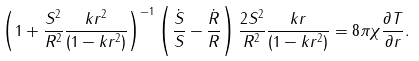Convert formula to latex. <formula><loc_0><loc_0><loc_500><loc_500>\left ( 1 + \frac { S ^ { 2 } } { R ^ { 2 } } \frac { k r ^ { 2 } } { ( 1 - k r ^ { 2 } ) } \right ) ^ { - 1 } \left ( \frac { \dot { S } } { S } - \frac { \dot { R } } { R } \right ) \frac { 2 S ^ { 2 } } { R ^ { 2 } } \frac { k r } { ( 1 - k r ^ { 2 } ) } = 8 \pi \chi \frac { \partial T } { \partial r } .</formula> 